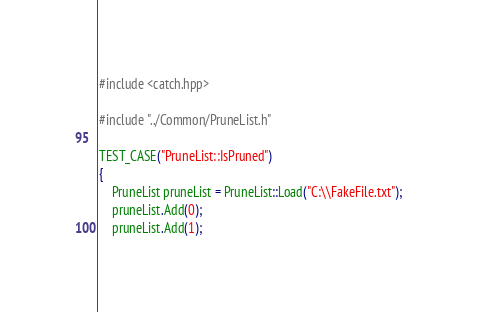<code> <loc_0><loc_0><loc_500><loc_500><_C++_>#include <catch.hpp>

#include "../Common/PruneList.h"

TEST_CASE("PruneList::IsPruned")
{
	PruneList pruneList = PruneList::Load("C:\\FakeFile.txt");
	pruneList.Add(0);
	pruneList.Add(1);</code> 